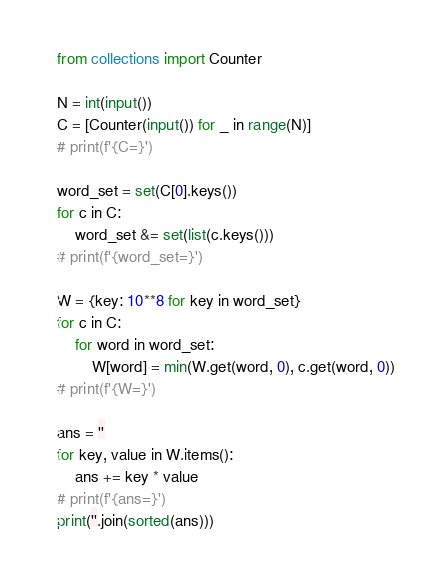Convert code to text. <code><loc_0><loc_0><loc_500><loc_500><_Python_>from collections import Counter

N = int(input())
C = [Counter(input()) for _ in range(N)]
# print(f'{C=}')

word_set = set(C[0].keys())
for c in C:
    word_set &= set(list(c.keys()))
# print(f'{word_set=}')

W = {key: 10**8 for key in word_set}
for c in C:
    for word in word_set:
        W[word] = min(W.get(word, 0), c.get(word, 0))
# print(f'{W=}')

ans = ''
for key, value in W.items():
    ans += key * value
# print(f'{ans=}')
print(''.join(sorted(ans)))
</code> 